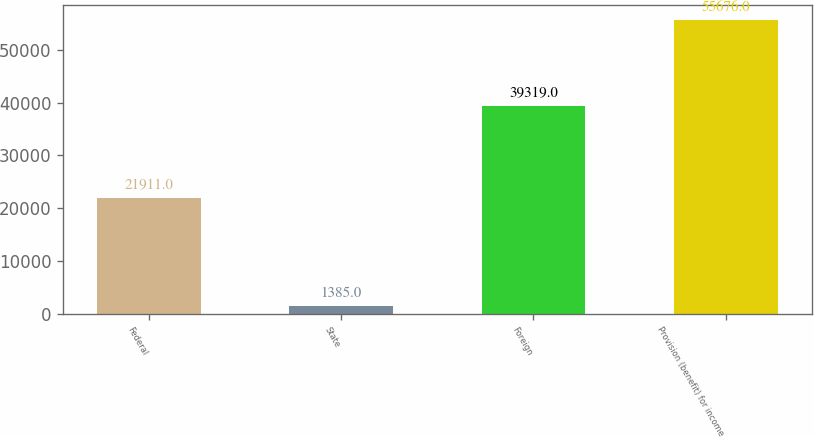Convert chart to OTSL. <chart><loc_0><loc_0><loc_500><loc_500><bar_chart><fcel>Federal<fcel>State<fcel>Foreign<fcel>Provision (benefit) for income<nl><fcel>21911<fcel>1385<fcel>39319<fcel>55676<nl></chart> 